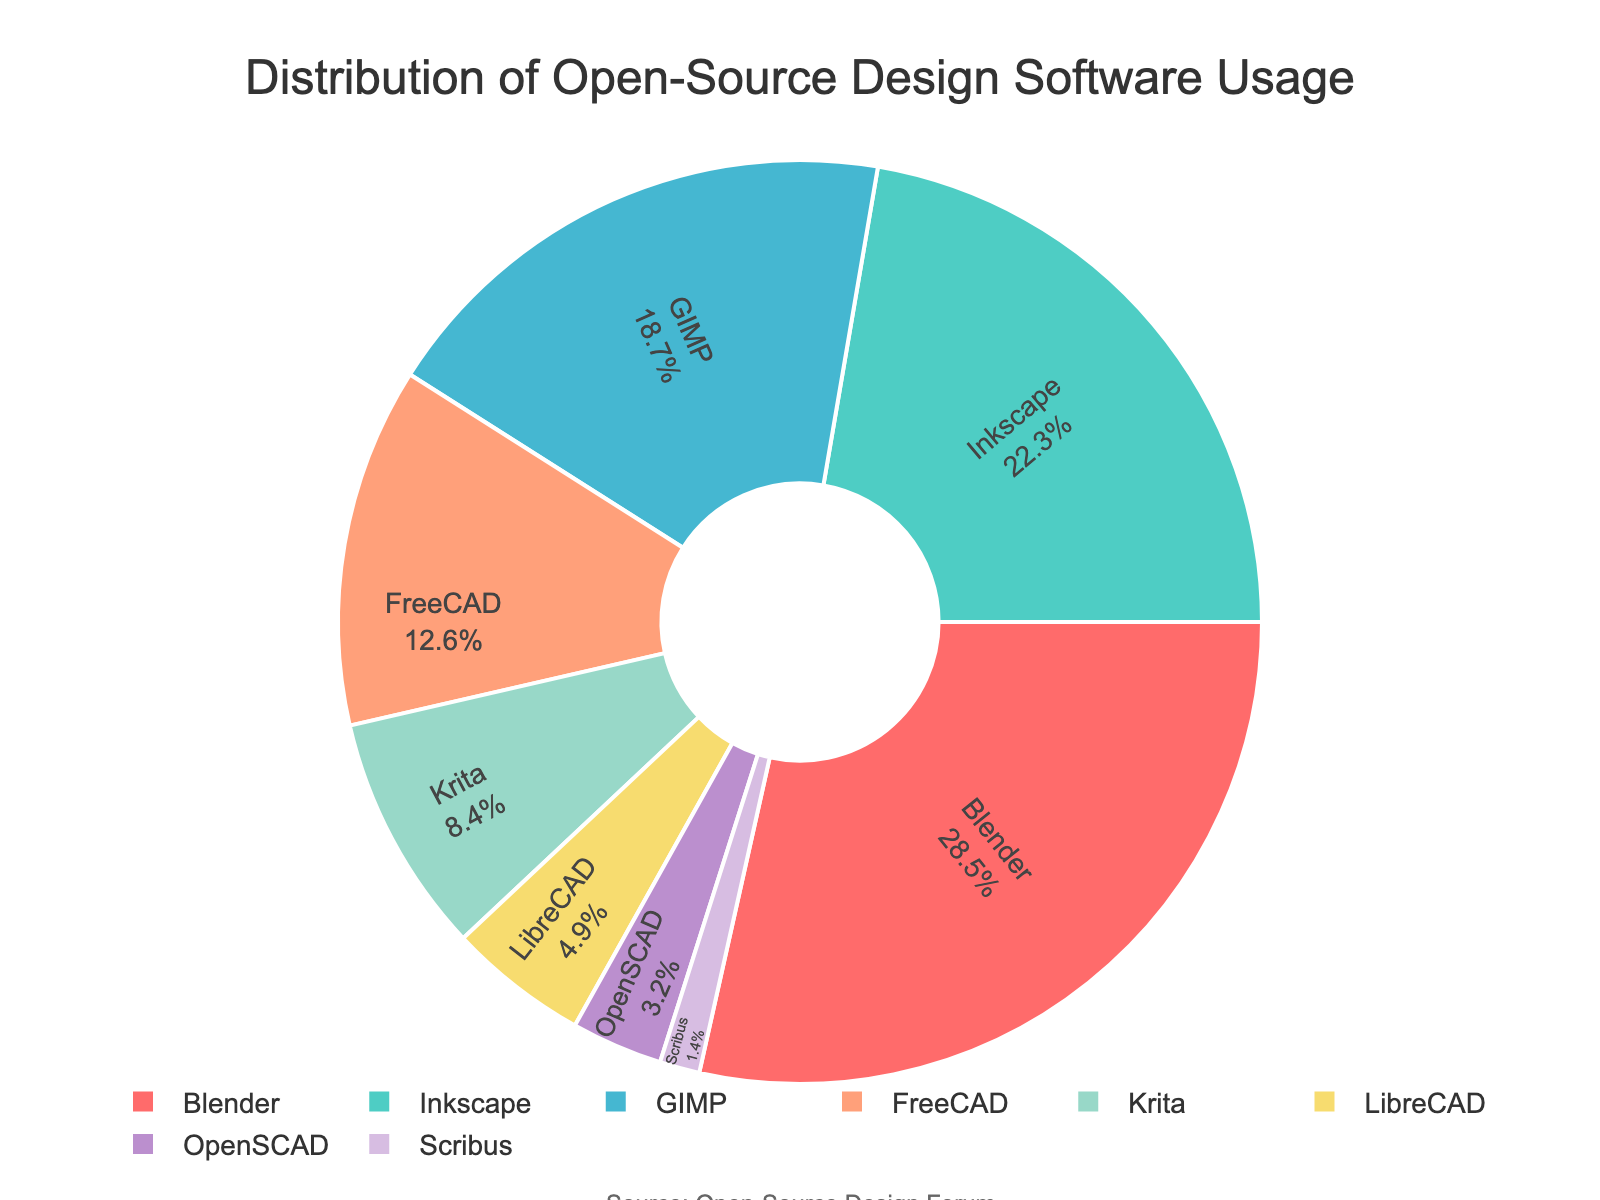What percentage of forum members use Blender? The pie chart shows that Blender is represented by a section labeled "Blender" with a percentage written inside it.
Answer: 28.5% Which software has a higher usage among forum members, FreeCAD or Krita? Compare the percentages associated with FreeCAD (12.6%) and Krita (8.4%) as seen in the pie chart. FreeCAD's percentage is higher than Krita's.
Answer: FreeCAD What is the total percentage of forum members that use GIMP and LibreCAD? Add the percentage values for GIMP (18.7%) and LibreCAD (4.9%) as indicated by their respective sections in the pie chart: 18.7% + 4.9% = 23.6%.
Answer: 23.6% Is Blender used by more than a quarter of the forum members? Check the percentage of Blender (28.5%) against the threshold of 25%. Since 28.5% is greater than 25%, Blender is used by more than a quarter of the forum members.
Answer: Yes What is the difference in usage percentage between Inkscape and Scribus? Subtract the percentage for Scribus (1.4%) from Inkscape's (22.3%): 22.3% - 1.4% = 20.9%.
Answer: 20.9% Which three software have the lowest usage among forum members? Identify the three software with the smallest percentages in the pie chart, which are Scribus (1.4%), OpenSCAD (3.2%), and LibreCAD (4.9%).
Answer: Scribus, OpenSCAD, LibreCAD What percentage of forum members use software other than Blender or Inkscape? Add the percentages of all software except Blender (28.5%) and Inkscape (22.3%): 18.7% (GIMP) + 12.6% (FreeCAD) + 8.4% (Krita) + 4.9% (LibreCAD) + 3.2% (OpenSCAD) + 1.4% (Scribus) = 49.2%.
Answer: 49.2% What is the combined percentage of forum members using Inkscape, GIMP, and Krita? Sum the percentages for Inkscape (22.3%), GIMP (18.7%), and Krita (8.4%): 22.3% + 18.7% + 8.4% = 49.4%.
Answer: 49.4% Which software is represented by a section in green color? The software sections in the pie chart are color-coded, and Inkscape is the section presented in green based on the color palette.
Answer: Inkscape Does any software have a usage percentage close to 20%? Look through the pie chart percentages to see if any software's usage is near 20%. Inkscape has a percentage of 22.3%, which is the closest to 20%.
Answer: Inkscape 